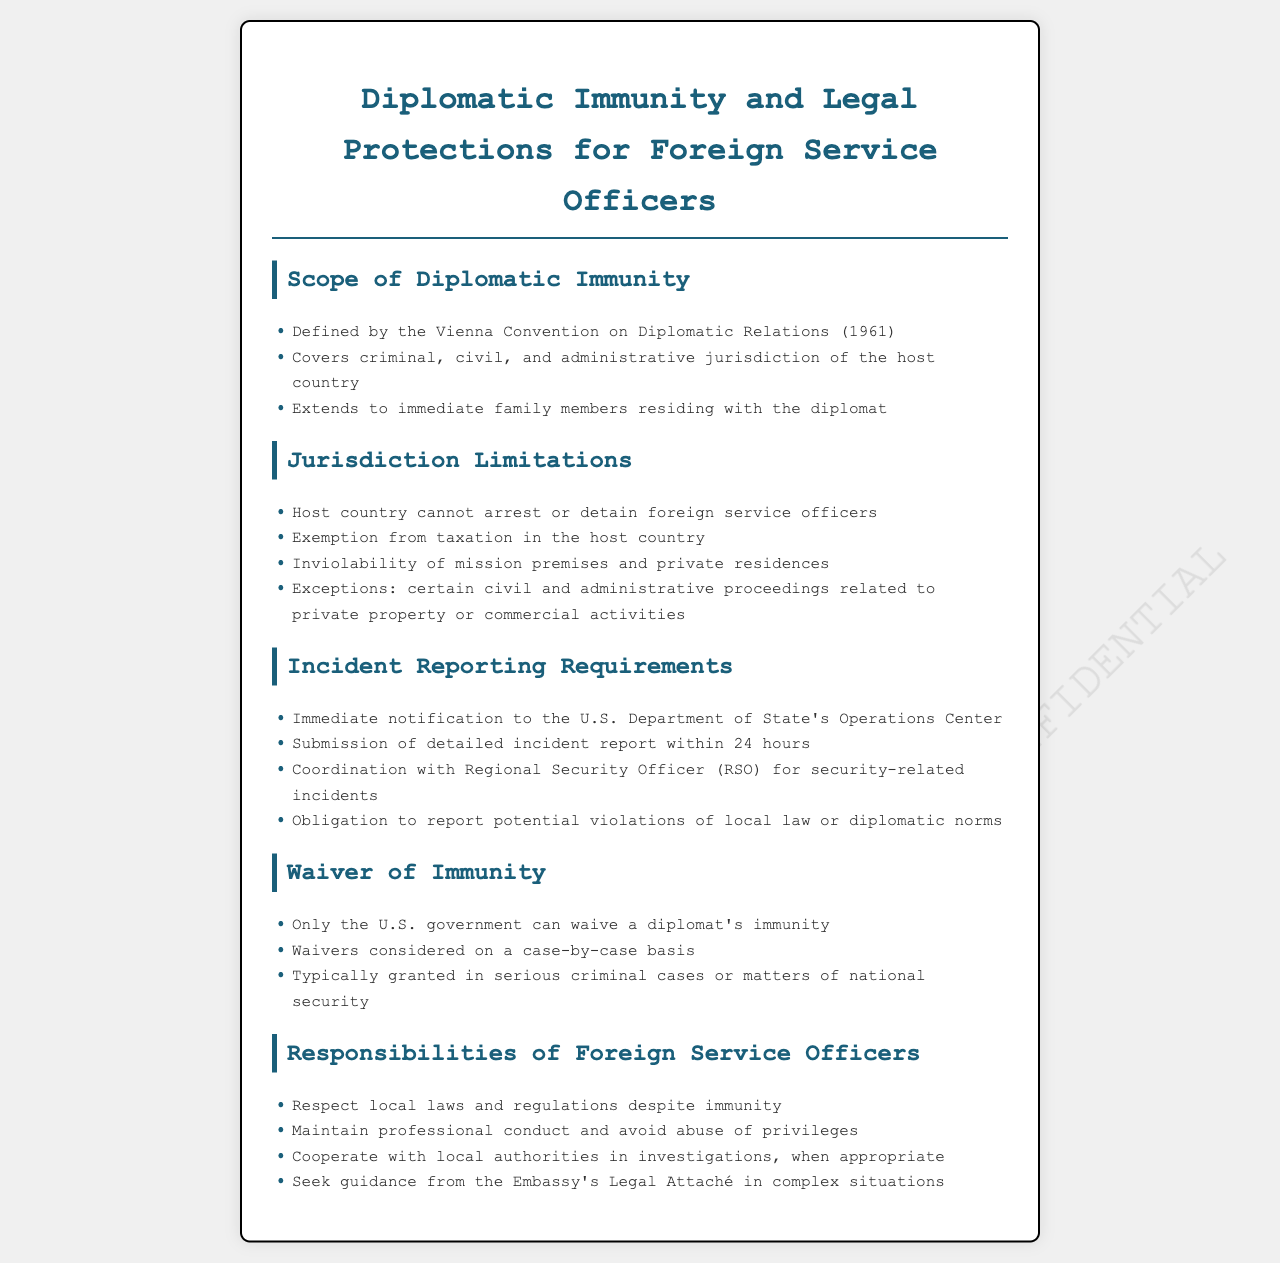what document defines diplomatic immunity? The document states that diplomatic immunity is defined by the Vienna Convention on Diplomatic Relations (1961).
Answer: Vienna Convention on Diplomatic Relations (1961) who is covered under diplomatic immunity? According to the document, diplomatic immunity extends to foreign service officers and their immediate family members residing with them.
Answer: Immediate family members what jurisdiction limitations exist for foreign service officers? The document outlines several limitations including exemption from taxes and inviolability of mission premises.
Answer: Exemption from taxation how soon must an incident be reported to the U.S. Department of State? The document specifies that detailed incident reports must be submitted within 24 hours of the incident.
Answer: 24 hours who can waive a diplomat's immunity? The document indicates that only the U.S. government has the authority to waive a diplomat's immunity.
Answer: U.S. government what should foreign service officers respect despite their immunity? Foreign service officers are required to respect local laws and regulations.
Answer: Local laws and regulations what must be coordinated with the Regional Security Officer (RSO)? The document mentions the need for coordination with the RSO for security-related incidents.
Answer: Security-related incidents in what instances might waivers of immunity be considered? The document states that waivers are typically considered in serious criminal cases or matters of national security.
Answer: Serious criminal cases what is one responsibility of foreign service officers regarding local investigations? The document indicates that foreign service officers should cooperate with local authorities in investigations when appropriate.
Answer: Cooperate with local authorities 